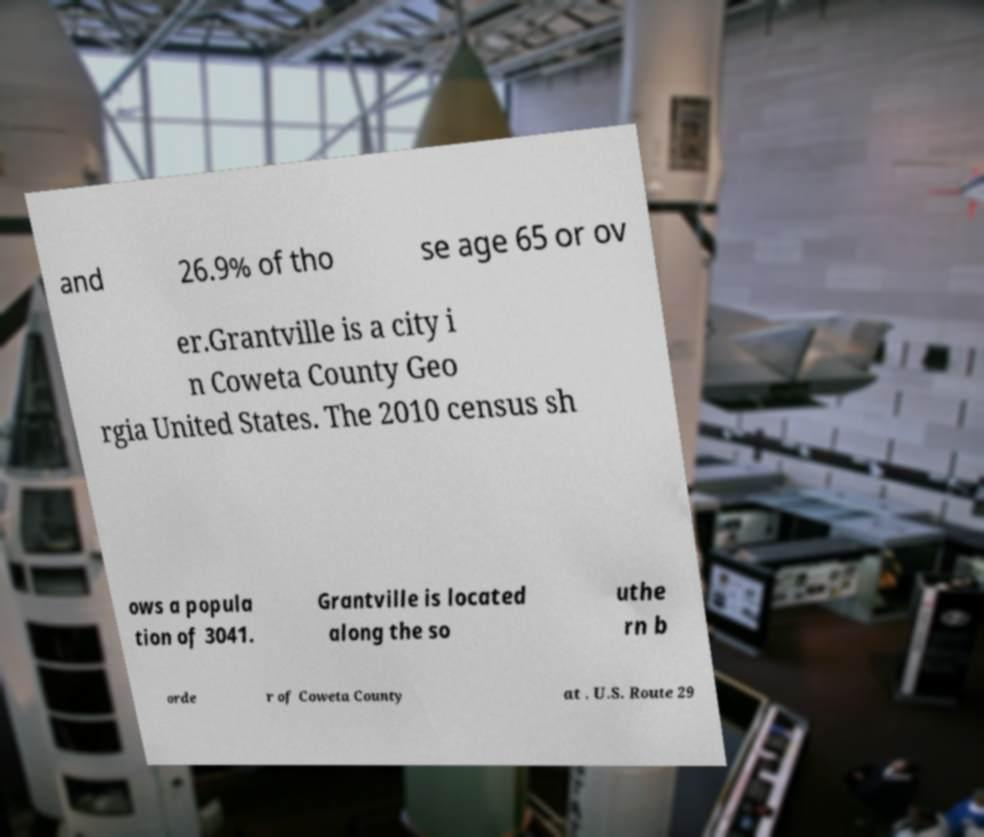Can you accurately transcribe the text from the provided image for me? and 26.9% of tho se age 65 or ov er.Grantville is a city i n Coweta County Geo rgia United States. The 2010 census sh ows a popula tion of 3041. Grantville is located along the so uthe rn b orde r of Coweta County at . U.S. Route 29 